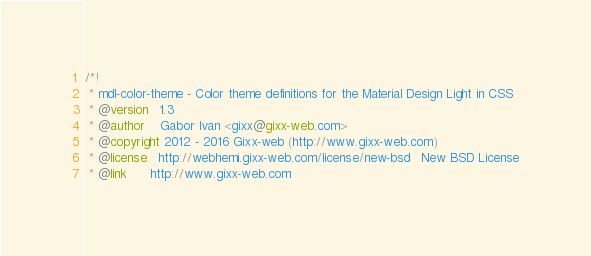<code> <loc_0><loc_0><loc_500><loc_500><_CSS_>/*!
 * mdl-color-theme - Color theme definitions for the Material Design Light in CSS
 * @version   1.3
 * @author    Gabor Ivan <gixx@gixx-web.com>
 * @copyright 2012 - 2016 Gixx-web (http://www.gixx-web.com)
 * @license   http://webhemi.gixx-web.com/license/new-bsd   New BSD License
 * @link      http://www.gixx-web.com</code> 